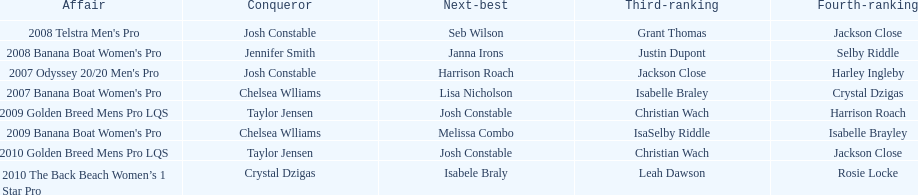Who was next to finish after josh constable in the 2008 telstra men's pro? Seb Wilson. 